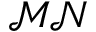Convert formula to latex. <formula><loc_0><loc_0><loc_500><loc_500>\mathcal { M N }</formula> 